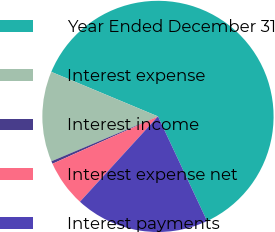Convert chart. <chart><loc_0><loc_0><loc_500><loc_500><pie_chart><fcel>Year Ended December 31<fcel>Interest expense<fcel>Interest income<fcel>Interest expense net<fcel>Interest payments<nl><fcel>61.72%<fcel>12.64%<fcel>0.37%<fcel>6.5%<fcel>18.77%<nl></chart> 